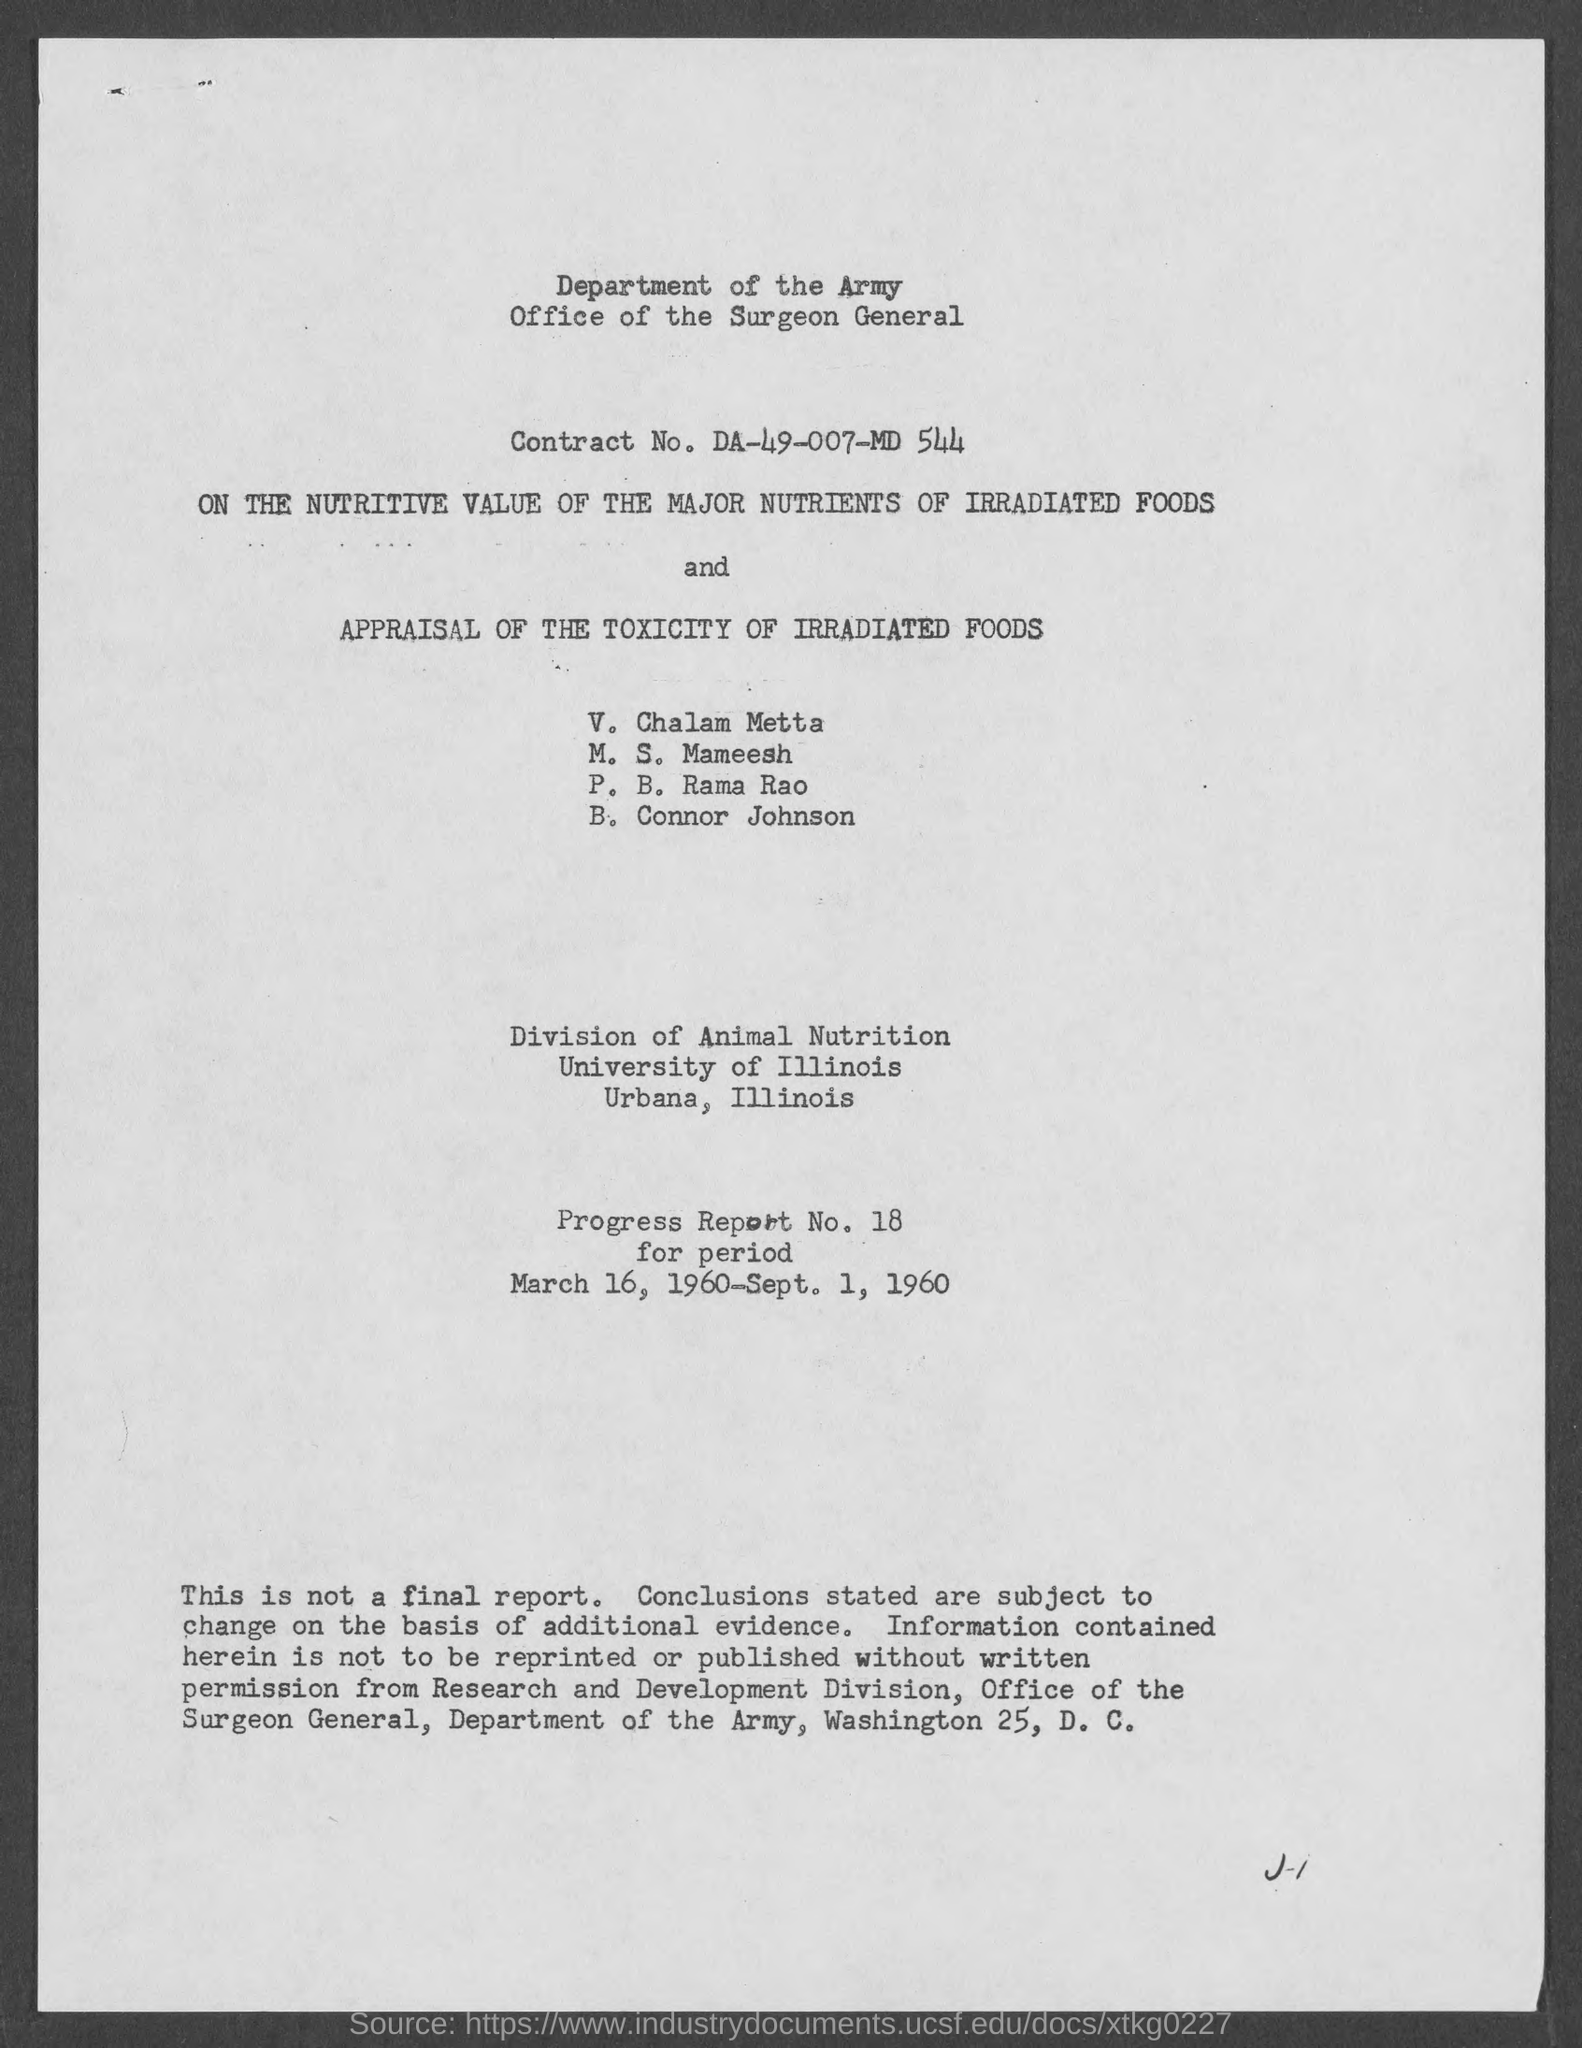What is the contract no. ?
Your answer should be very brief. DA-49-007-MD 544. What is the progress report no.?
Ensure brevity in your answer.  Progress Report No. 18. What is the period of progress report ?
Your answer should be compact. March 16, 1960- Sept. 1, 1960. 